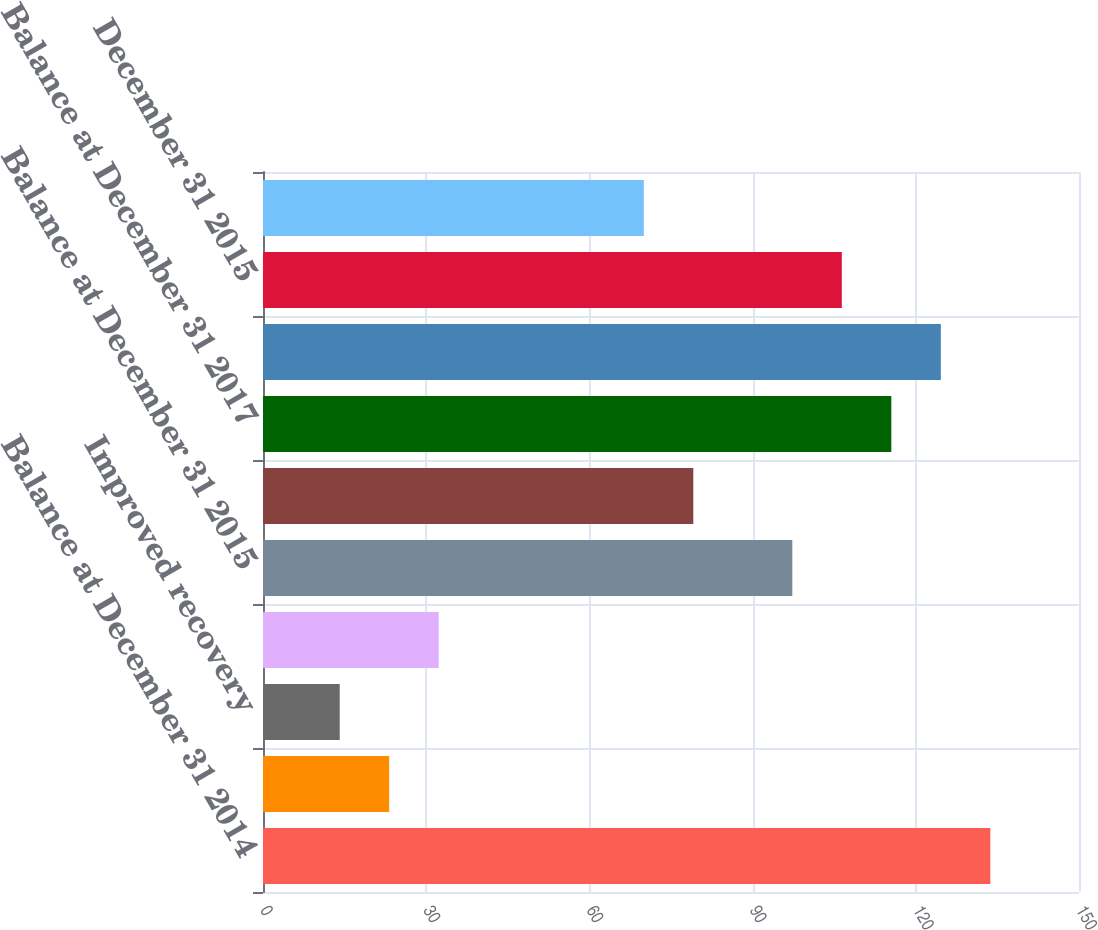Convert chart to OTSL. <chart><loc_0><loc_0><loc_500><loc_500><bar_chart><fcel>Balance at December 31 2014<fcel>Revisions of previous<fcel>Improved recovery<fcel>Production<fcel>Balance at December 31 2015<fcel>Balance at December 31 2016<fcel>Balance at December 31 2017<fcel>December 31 2014<fcel>December 31 2015<fcel>December 31 2016<nl><fcel>133.7<fcel>23.2<fcel>14.1<fcel>32.3<fcel>97.3<fcel>79.1<fcel>115.5<fcel>124.6<fcel>106.4<fcel>70<nl></chart> 